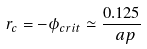Convert formula to latex. <formula><loc_0><loc_0><loc_500><loc_500>r _ { c } = - \phi _ { c r i t } \simeq \frac { 0 . 1 2 5 } { \ a p }</formula> 